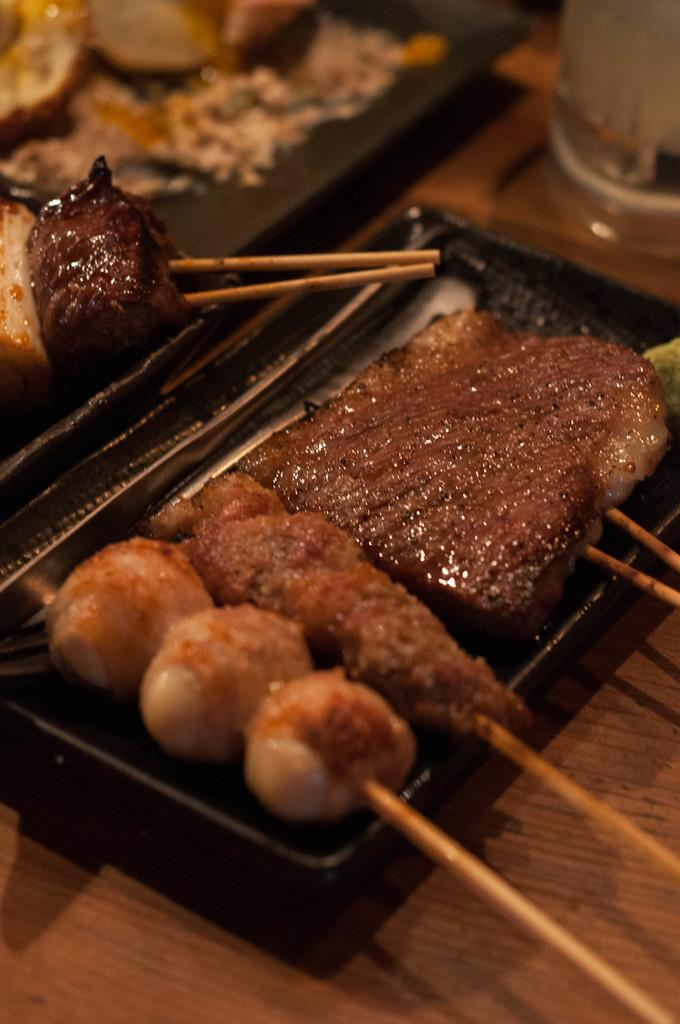What is on the plate that is visible in the image? There are food items on a plate in the image. What is the color of the plate? The plate is black in color. What is the color of the table in the image? The table is brown in color. What else can be seen on the table in the image? There are objects on the table in the image. Can you see a giraffe walking down the alley in the image? There is no giraffe or alley present in the image; it features a plate with food items on a table. 